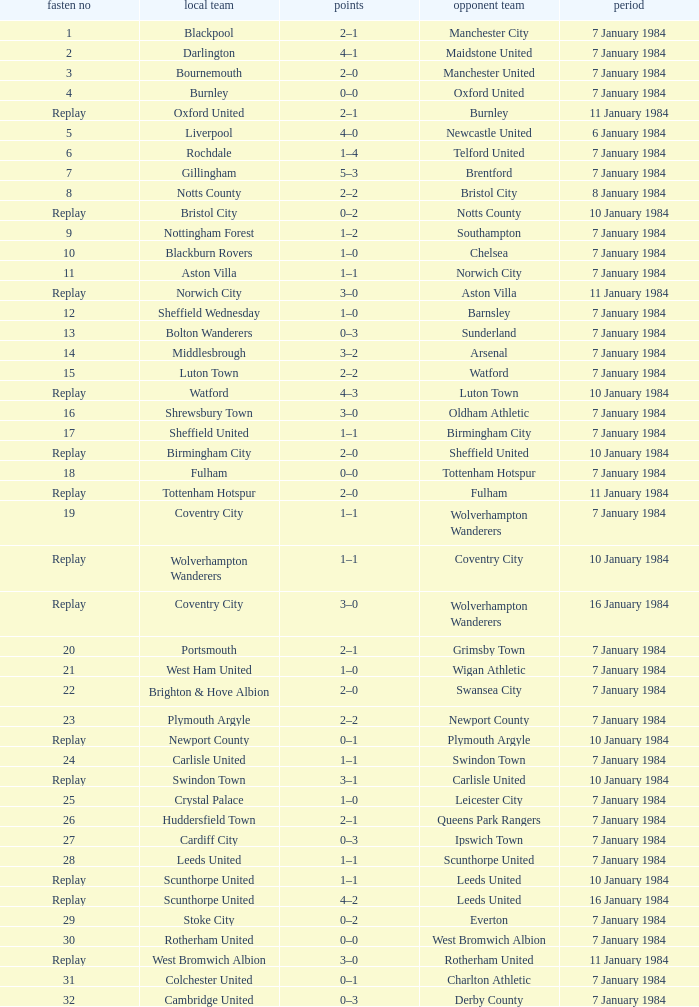Would you mind parsing the complete table? {'header': ['fasten no', 'local team', 'points', 'opponent team', 'period'], 'rows': [['1', 'Blackpool', '2–1', 'Manchester City', '7 January 1984'], ['2', 'Darlington', '4–1', 'Maidstone United', '7 January 1984'], ['3', 'Bournemouth', '2–0', 'Manchester United', '7 January 1984'], ['4', 'Burnley', '0–0', 'Oxford United', '7 January 1984'], ['Replay', 'Oxford United', '2–1', 'Burnley', '11 January 1984'], ['5', 'Liverpool', '4–0', 'Newcastle United', '6 January 1984'], ['6', 'Rochdale', '1–4', 'Telford United', '7 January 1984'], ['7', 'Gillingham', '5–3', 'Brentford', '7 January 1984'], ['8', 'Notts County', '2–2', 'Bristol City', '8 January 1984'], ['Replay', 'Bristol City', '0–2', 'Notts County', '10 January 1984'], ['9', 'Nottingham Forest', '1–2', 'Southampton', '7 January 1984'], ['10', 'Blackburn Rovers', '1–0', 'Chelsea', '7 January 1984'], ['11', 'Aston Villa', '1–1', 'Norwich City', '7 January 1984'], ['Replay', 'Norwich City', '3–0', 'Aston Villa', '11 January 1984'], ['12', 'Sheffield Wednesday', '1–0', 'Barnsley', '7 January 1984'], ['13', 'Bolton Wanderers', '0–3', 'Sunderland', '7 January 1984'], ['14', 'Middlesbrough', '3–2', 'Arsenal', '7 January 1984'], ['15', 'Luton Town', '2–2', 'Watford', '7 January 1984'], ['Replay', 'Watford', '4–3', 'Luton Town', '10 January 1984'], ['16', 'Shrewsbury Town', '3–0', 'Oldham Athletic', '7 January 1984'], ['17', 'Sheffield United', '1–1', 'Birmingham City', '7 January 1984'], ['Replay', 'Birmingham City', '2–0', 'Sheffield United', '10 January 1984'], ['18', 'Fulham', '0–0', 'Tottenham Hotspur', '7 January 1984'], ['Replay', 'Tottenham Hotspur', '2–0', 'Fulham', '11 January 1984'], ['19', 'Coventry City', '1–1', 'Wolverhampton Wanderers', '7 January 1984'], ['Replay', 'Wolverhampton Wanderers', '1–1', 'Coventry City', '10 January 1984'], ['Replay', 'Coventry City', '3–0', 'Wolverhampton Wanderers', '16 January 1984'], ['20', 'Portsmouth', '2–1', 'Grimsby Town', '7 January 1984'], ['21', 'West Ham United', '1–0', 'Wigan Athletic', '7 January 1984'], ['22', 'Brighton & Hove Albion', '2–0', 'Swansea City', '7 January 1984'], ['23', 'Plymouth Argyle', '2–2', 'Newport County', '7 January 1984'], ['Replay', 'Newport County', '0–1', 'Plymouth Argyle', '10 January 1984'], ['24', 'Carlisle United', '1–1', 'Swindon Town', '7 January 1984'], ['Replay', 'Swindon Town', '3–1', 'Carlisle United', '10 January 1984'], ['25', 'Crystal Palace', '1–0', 'Leicester City', '7 January 1984'], ['26', 'Huddersfield Town', '2–1', 'Queens Park Rangers', '7 January 1984'], ['27', 'Cardiff City', '0–3', 'Ipswich Town', '7 January 1984'], ['28', 'Leeds United', '1–1', 'Scunthorpe United', '7 January 1984'], ['Replay', 'Scunthorpe United', '1–1', 'Leeds United', '10 January 1984'], ['Replay', 'Scunthorpe United', '4–2', 'Leeds United', '16 January 1984'], ['29', 'Stoke City', '0–2', 'Everton', '7 January 1984'], ['30', 'Rotherham United', '0–0', 'West Bromwich Albion', '7 January 1984'], ['Replay', 'West Bromwich Albion', '3–0', 'Rotherham United', '11 January 1984'], ['31', 'Colchester United', '0–1', 'Charlton Athletic', '7 January 1984'], ['32', 'Cambridge United', '0–3', 'Derby County', '7 January 1984']]} Who was the away team with a tie of 14? Arsenal. 